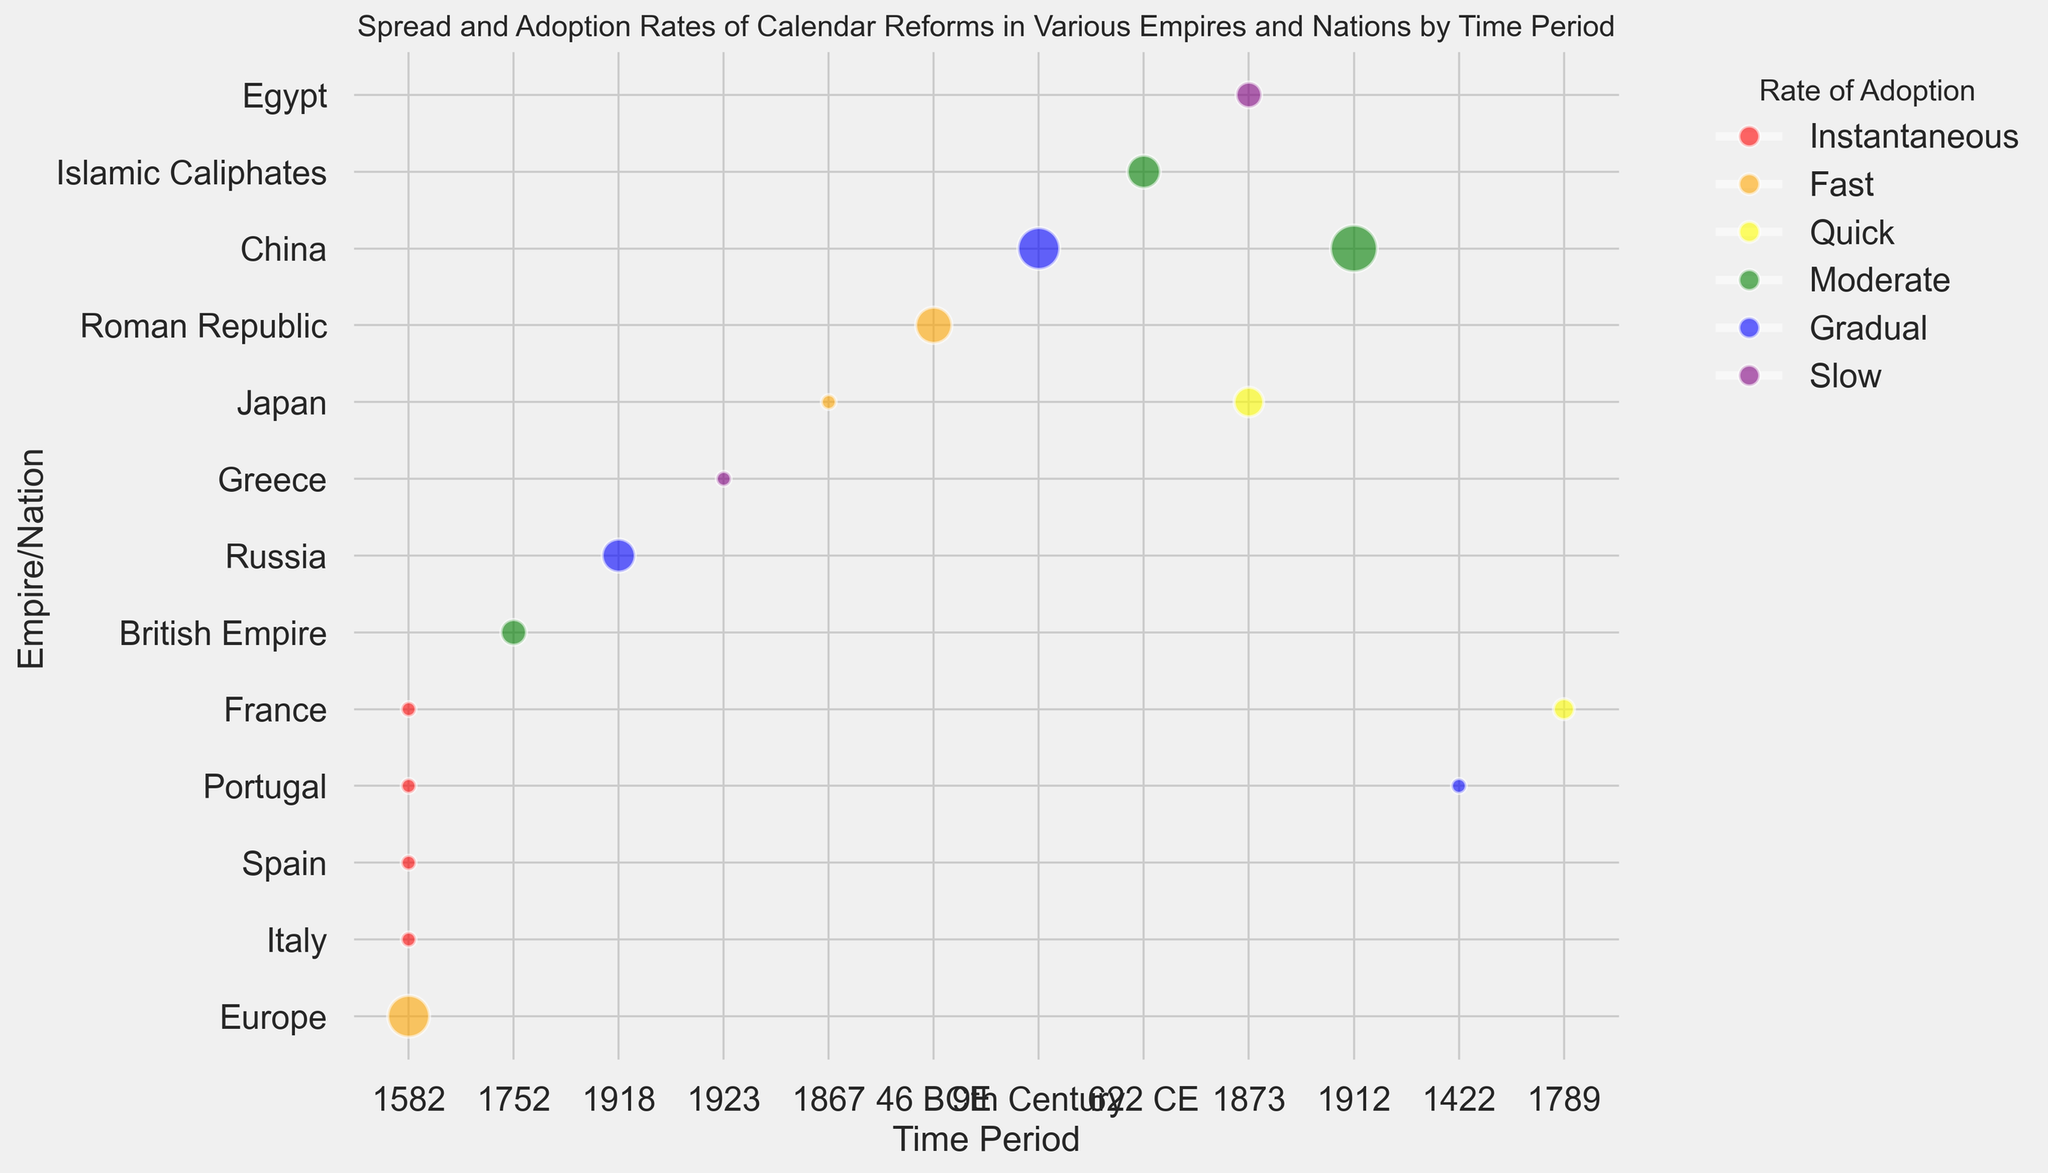Which empire/nation adopted the Gregorian Calendar the fastest? Based on the color scheme, "Fast" is indicated by orange. The nations with this color adopting the Gregorian Calendar are Europe and Japan (1867). As Italy, Spain, Portugal, and France adopted it instantaneously, they adopted it the fastest with the "red" color indicating instantaneous adoption.
Answer: Italy, Spain, Portugal, France Which nation took the longest to adopt a new calendar based on the color and size? The color "purple" indicates a "Slow" adoption rate. Comparing the sizes among "Slow" adoption rates, the nation with the largest size is Egypt, indicating it took the longest based on this color and size combination.
Answer: Egypt How many empires/nations adopted calendar reforms gradually? The color "blue" indicates a "Gradual" adoption rate. From the visual data, the empires/nations with blue bubbles are Russia, China, and Portugal (1422). Counting these, there are three.
Answer: 3 Which calendar reform was adopted by the most empires/nations? By examining the number of bubbles associated with each calendar reform, the Gregorian Calendar has the most bubbles including Europe, Italy, Spain, Portugal, France, British Empire, Russia, Greece, Japan, and China.
Answer: Gregorian Calendar What is the difference in adoption rate between the Roman Republic and the 9th Century China? The Roman Republic adopted the Julian Calendar with a "Fast" rate (orange), and China in the 9th Century adopted the Luni-Solar Calendar gradually (blue). Fast adoption is quicker than gradual adoption.
Answer: Fast vs Gradual Which period shows the highest diversity in adoption rates for calendar reforms? The period of 1582 shows the highest diversity with different adoption rates including "Instantaneous" (red for Italy, Spain, Portugal, France) and "Fast" (orange for Europe).
Answer: 1582 Compare the sizes of bubbles for the Gregorian Calendar in Europe and the British Empire. The size for Europe is 40, and for the British Empire, it is 15. Europe has a significantly larger bubble indicating a broader adoption impact.
Answer: Europe is larger Which empire/nation adopted the Julian Calendar to Gregorian Calendar reform gradually? According to the visual representation with "Gradual" adoption (blue), Portugal adopted the reform gradually.
Answer: Portugal 